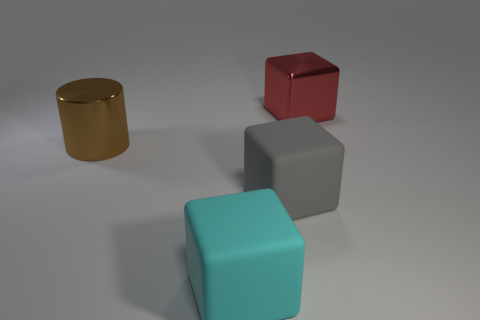There is a gray object that is the same size as the cyan matte block; what is its material?
Offer a terse response. Rubber. Are there any large red blocks in front of the big shiny object that is in front of the metal block?
Ensure brevity in your answer.  No. What is the size of the red thing?
Your answer should be compact. Large. Is there a big brown metal object?
Ensure brevity in your answer.  Yes. Is the number of red cubes that are behind the big cyan rubber object greater than the number of red cubes that are to the right of the gray matte cube?
Your response must be concise. No. There is a object that is behind the large gray rubber thing and left of the red metallic object; what is it made of?
Give a very brief answer. Metal. Do the large brown thing and the large gray matte thing have the same shape?
Offer a very short reply. No. Is there anything else that has the same size as the shiny block?
Offer a very short reply. Yes. There is a gray matte object; what number of cubes are in front of it?
Offer a terse response. 1. There is a object behind the cylinder; is it the same size as the gray object?
Provide a short and direct response. Yes. 